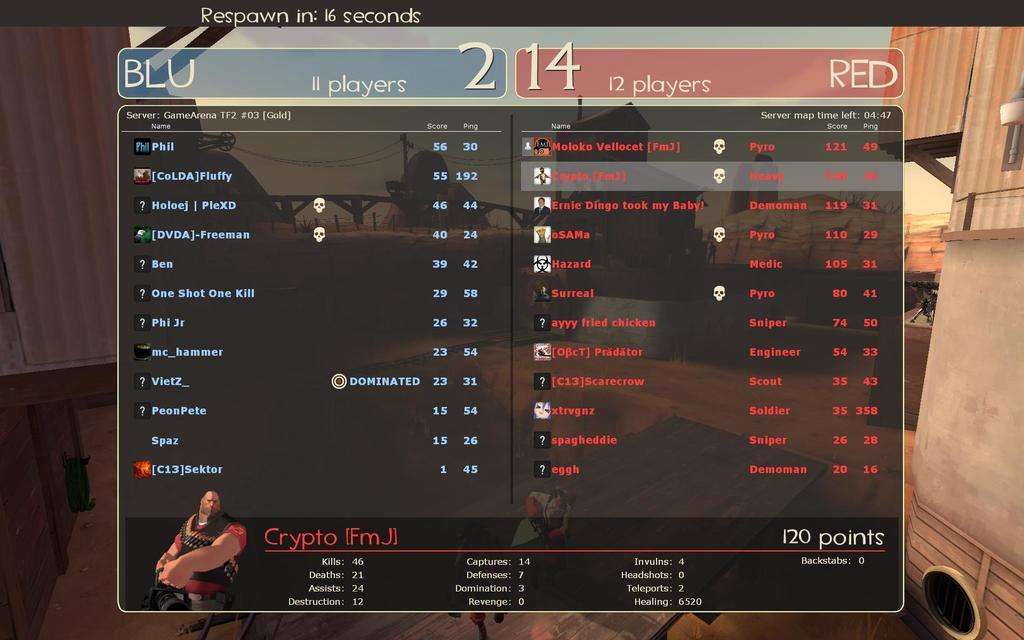<image>
Create a compact narrative representing the image presented. A video game screen shows that team Blu has 11 players and team Red has 12 players. 